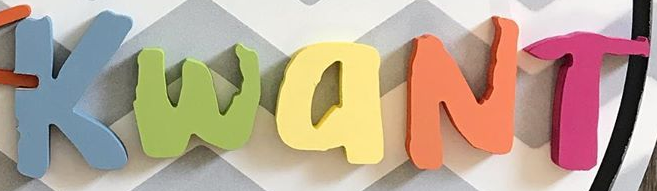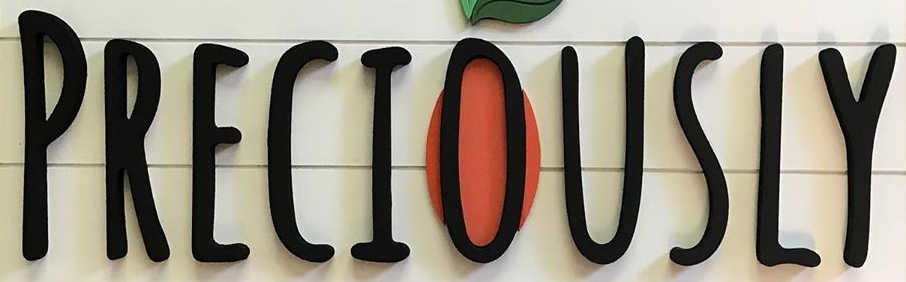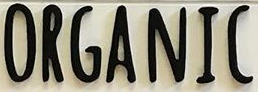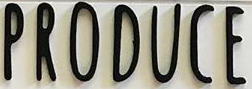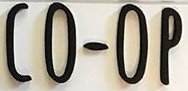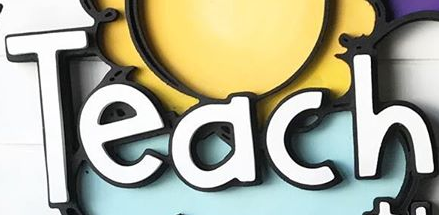What text appears in these images from left to right, separated by a semicolon? KwaNT; PRECIOUSLY; ORGANIC; PRODUCE; CO-OP; Teach 